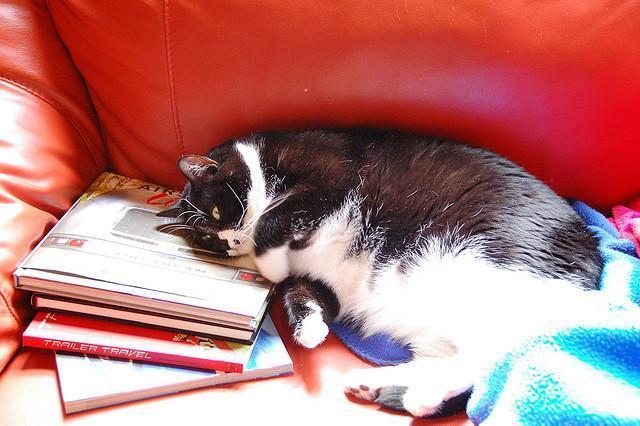How many books are there?
Give a very brief answer. 4. How many surfboards are in the picture?
Give a very brief answer. 0. 